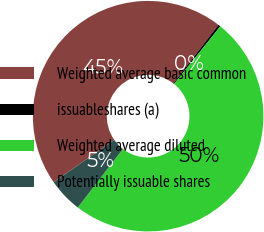<chart> <loc_0><loc_0><loc_500><loc_500><pie_chart><fcel>Weighted average basic common<fcel>issuableshares (a)<fcel>Weighted average diluted<fcel>Potentially issuable shares<nl><fcel>45.16%<fcel>0.32%<fcel>49.68%<fcel>4.84%<nl></chart> 